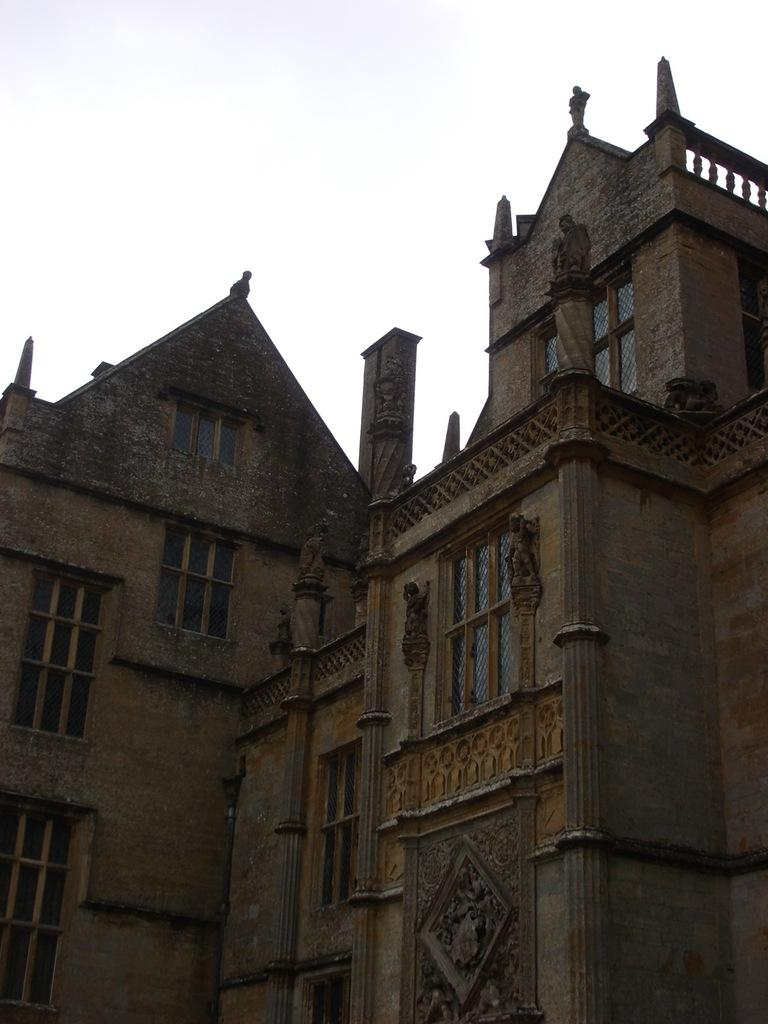What type of structure is present in the image? There is a building in the image. What is the color of the building? The building is brown in color. Are there any specific features of the building? Yes, there are windows in the building. What can be seen in the background of the image? The sky in the background is white in color. What is the rate of the ground in the image? There is no rate associated with the ground in the image; it is a stationary surface. 